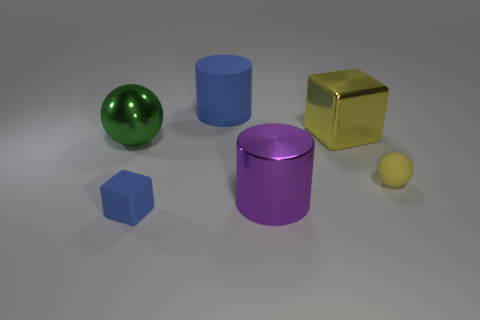What is the material of the purple thing that is the same size as the green ball?
Offer a terse response. Metal. How many blue shiny cylinders are there?
Offer a terse response. 0. There is a ball right of the yellow shiny object; what size is it?
Your response must be concise. Small. Are there an equal number of blocks in front of the purple cylinder and big blue matte cylinders?
Provide a succinct answer. Yes. Are there any big purple rubber objects that have the same shape as the big yellow object?
Keep it short and to the point. No. The matte object that is both behind the purple shiny cylinder and in front of the blue rubber cylinder has what shape?
Give a very brief answer. Sphere. Do the yellow cube and the cube that is in front of the yellow ball have the same material?
Your response must be concise. No. There is a small blue thing; are there any purple metal cylinders to the left of it?
Provide a short and direct response. No. How many objects are either large yellow objects or blue matte objects that are behind the big metal cube?
Your answer should be compact. 2. What color is the shiny thing that is in front of the tiny yellow object that is to the right of the rubber cube?
Keep it short and to the point. Purple. 